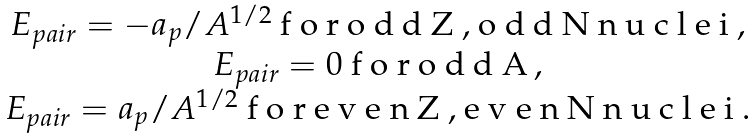Convert formula to latex. <formula><loc_0><loc_0><loc_500><loc_500>\begin{array} { c c c } E _ { p a i r } = - a { _ { p } } / A ^ { 1 / 2 } $ f o r o d d Z , o d d N n u c l e i $ , \\ E _ { p a i r } = 0 $ f o r o d d A $ , \\ E _ { p a i r } = a { _ { p } } / A ^ { 1 / 2 } $ f o r e v e n Z , e v e n N n u c l e i $ . \end{array}</formula> 